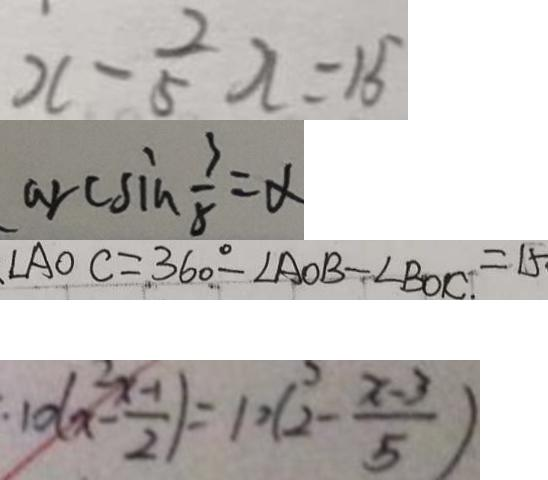<formula> <loc_0><loc_0><loc_500><loc_500>x - \frac { 2 } { 5 } x = 1 5 
 \arcsin \frac { 3 } { 8 } = \alpha 
 \angle A O C = 3 6 0 ^ { \circ } - \angle A O B - \angle B O C = 1 5 
 1 0 ( x - \frac { x - 1 } { 2 } ) = 1 0 ( 2 - \frac { x - 3 } { 5 } )</formula> 